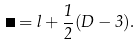<formula> <loc_0><loc_0><loc_500><loc_500>\Lambda = l + \frac { 1 } { 2 } ( D - 3 ) .</formula> 